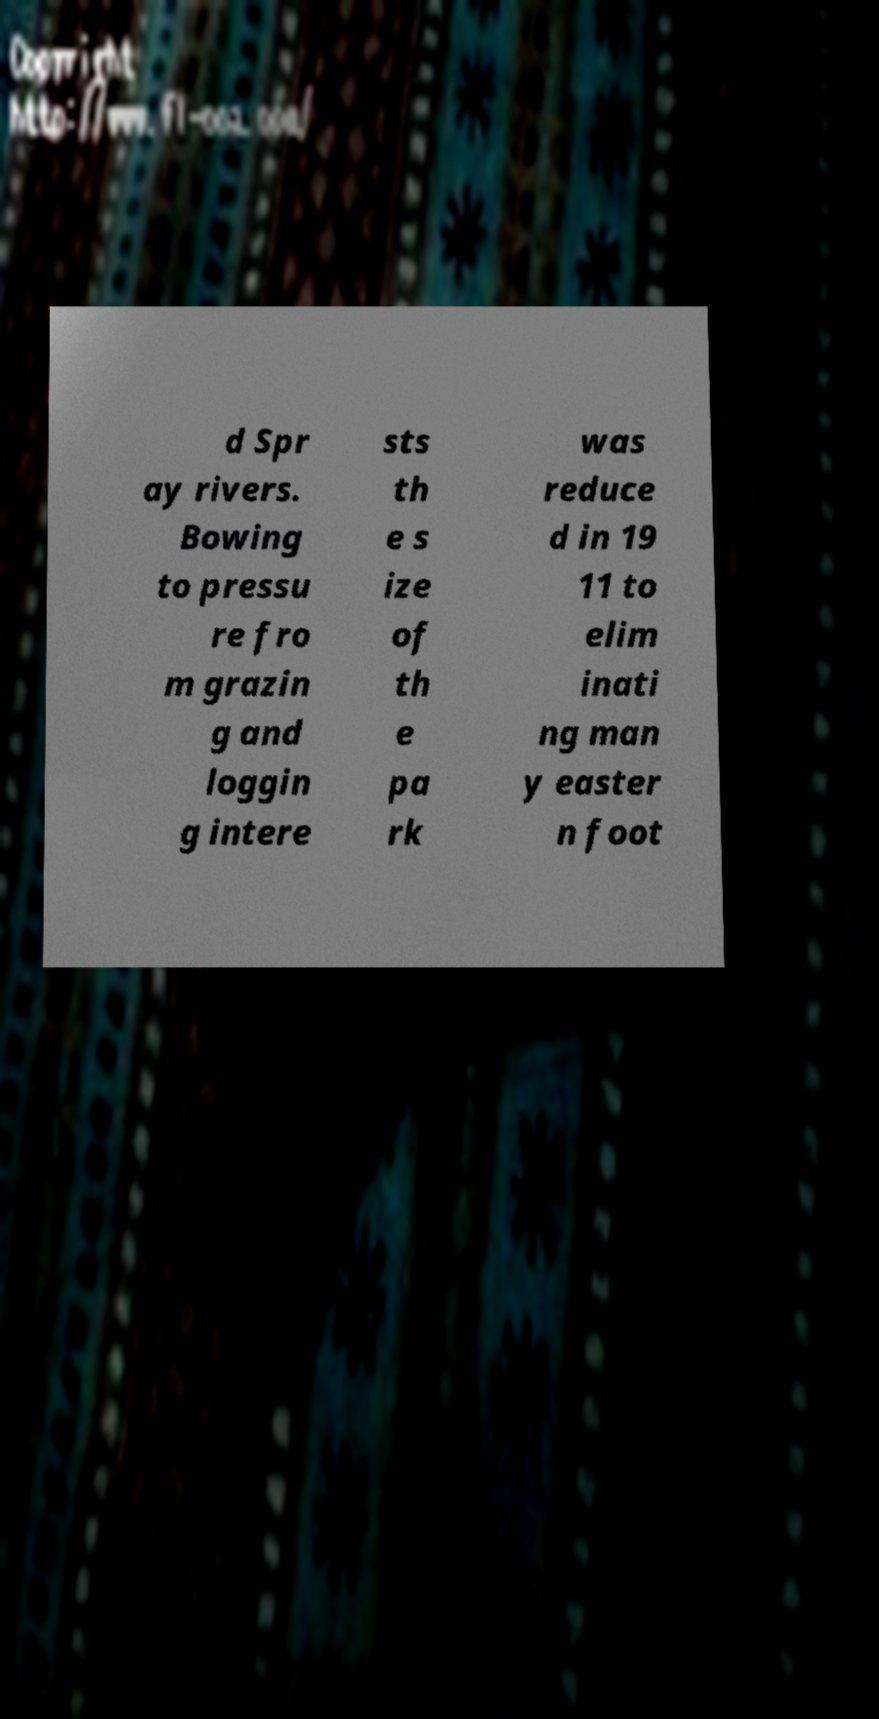Can you accurately transcribe the text from the provided image for me? d Spr ay rivers. Bowing to pressu re fro m grazin g and loggin g intere sts th e s ize of th e pa rk was reduce d in 19 11 to elim inati ng man y easter n foot 